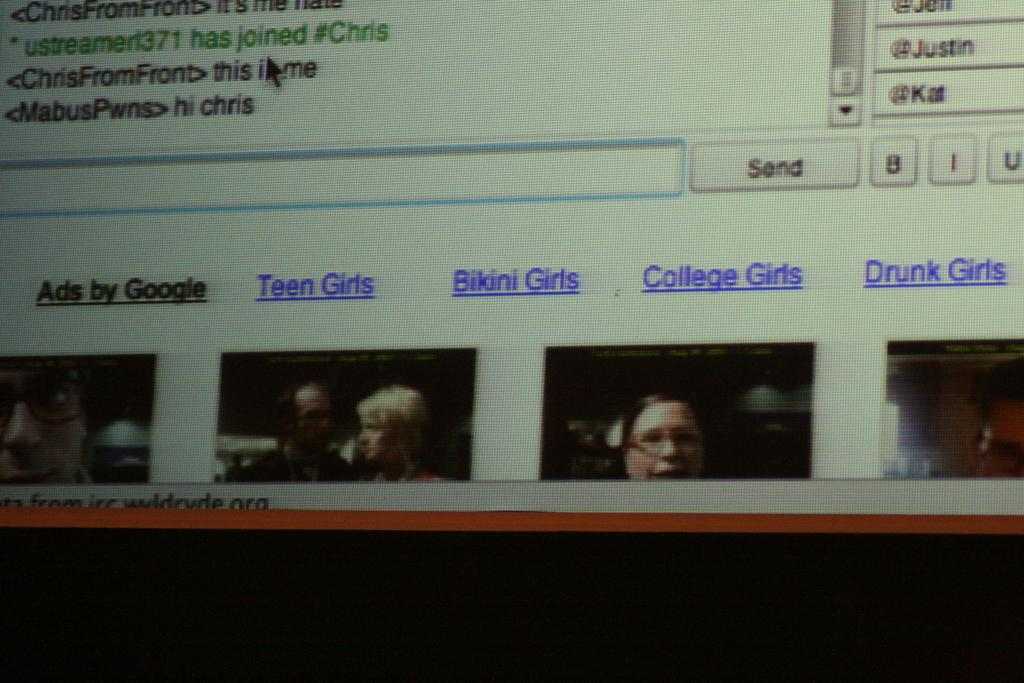What is the main object in the image? There is a screen in the image. What can be seen on the screen? There is text visible on the screen, and there are images of persons on the screen. What type of underwear is visible on the screen? There is no underwear visible on the screen; it only displays text and images of persons. Is there a guitar being played by one of the persons on the screen? There is no guitar or any indication of a guitar being played by any of the persons on the screen. 